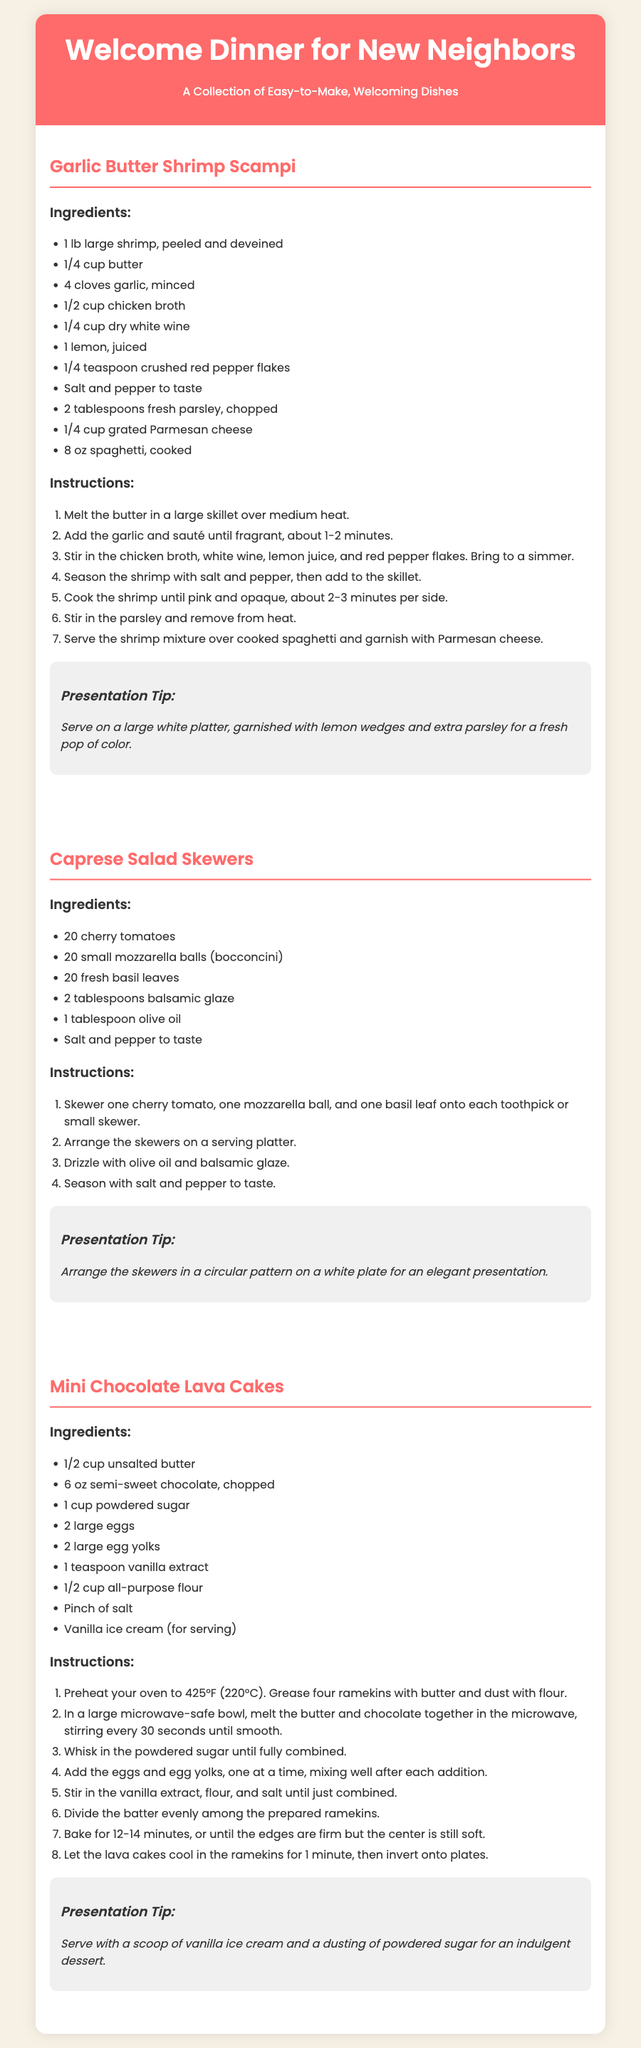What is the title of the recipe collection? The title of the recipe collection is indicated at the top of the document.
Answer: Welcome Dinner for New Neighbors How many ingredients are needed for Garlic Butter Shrimp Scampi? The number of ingredients is noted in the ingredients section for the Garlic Butter Shrimp Scampi recipe.
Answer: 10 What is the main ingredient in Caprese Salad Skewers? The main ingredients of the Caprese Salad Skewers are listed in the ingredients section.
Answer: Cherry tomatoes How long should the Mini Chocolate Lava Cakes be baked? The baking time is specified in the instructions section for the Mini Chocolate Lava Cakes.
Answer: 12-14 minutes What is a suggested presentation tip for Garlic Butter Shrimp Scampi? The presentation tips section highlights how to beautifully serve the dish.
Answer: Serve on a large white platter How many cherry tomatoes are used in the Caprese Salad Skewers? The quantity of cherry tomatoes is listed in the ingredients section of the Caprese Salad Skewers recipe.
Answer: 20 What type of wine is recommended for Garlic Butter Shrimp Scampi? The ingredients specify a kind of wine needed for the recipe.
Answer: Dry white wine What is included for serving with Mini Chocolate Lava Cakes? The serving suggestion is provided in the presentation tips section for the dessert.
Answer: Vanilla ice cream 